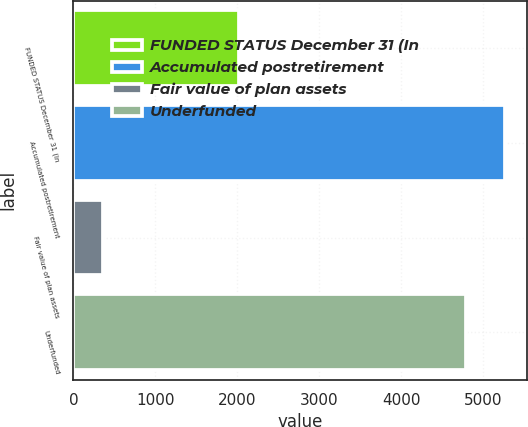Convert chart. <chart><loc_0><loc_0><loc_500><loc_500><bar_chart><fcel>FUNDED STATUS December 31 (In<fcel>Accumulated postretirement<fcel>Fair value of plan assets<fcel>Underfunded<nl><fcel>2018<fcel>5270.1<fcel>362<fcel>4791<nl></chart> 